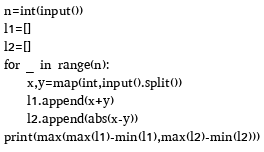<code> <loc_0><loc_0><loc_500><loc_500><_Python_>n=int(input())
l1=[]
l2=[]
for _ in range(n):
    x,y=map(int,input().split())
    l1.append(x+y)
    l2.append(abs(x-y))
print(max(max(l1)-min(l1),max(l2)-min(l2)))</code> 